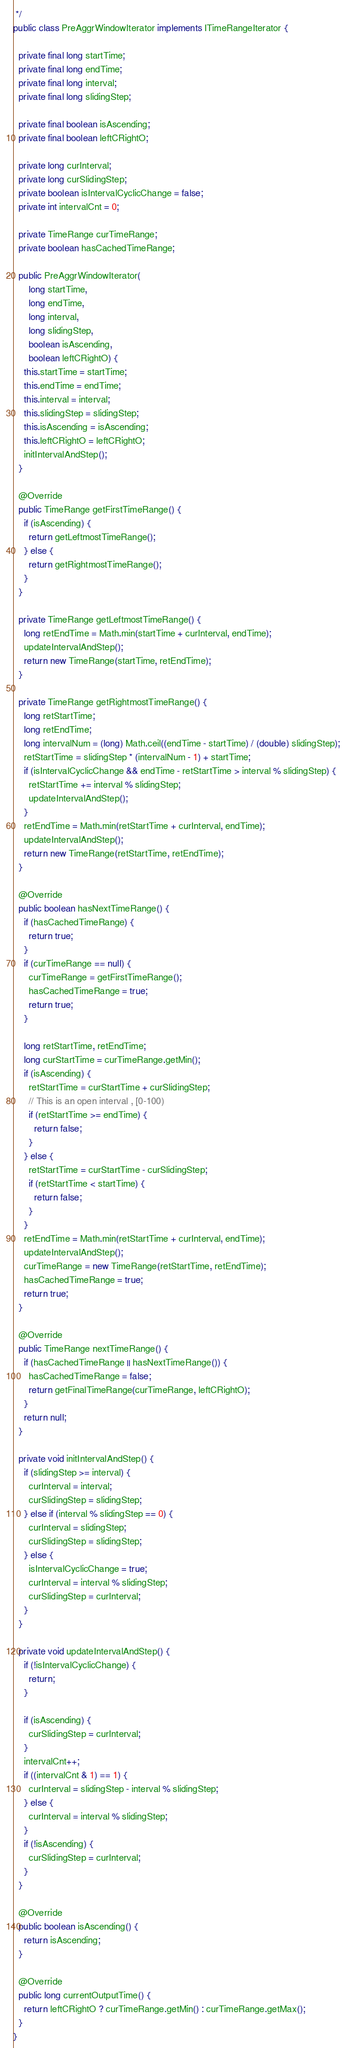Convert code to text. <code><loc_0><loc_0><loc_500><loc_500><_Java_> */
public class PreAggrWindowIterator implements ITimeRangeIterator {

  private final long startTime;
  private final long endTime;
  private final long interval;
  private final long slidingStep;

  private final boolean isAscending;
  private final boolean leftCRightO;

  private long curInterval;
  private long curSlidingStep;
  private boolean isIntervalCyclicChange = false;
  private int intervalCnt = 0;

  private TimeRange curTimeRange;
  private boolean hasCachedTimeRange;

  public PreAggrWindowIterator(
      long startTime,
      long endTime,
      long interval,
      long slidingStep,
      boolean isAscending,
      boolean leftCRightO) {
    this.startTime = startTime;
    this.endTime = endTime;
    this.interval = interval;
    this.slidingStep = slidingStep;
    this.isAscending = isAscending;
    this.leftCRightO = leftCRightO;
    initIntervalAndStep();
  }

  @Override
  public TimeRange getFirstTimeRange() {
    if (isAscending) {
      return getLeftmostTimeRange();
    } else {
      return getRightmostTimeRange();
    }
  }

  private TimeRange getLeftmostTimeRange() {
    long retEndTime = Math.min(startTime + curInterval, endTime);
    updateIntervalAndStep();
    return new TimeRange(startTime, retEndTime);
  }

  private TimeRange getRightmostTimeRange() {
    long retStartTime;
    long retEndTime;
    long intervalNum = (long) Math.ceil((endTime - startTime) / (double) slidingStep);
    retStartTime = slidingStep * (intervalNum - 1) + startTime;
    if (isIntervalCyclicChange && endTime - retStartTime > interval % slidingStep) {
      retStartTime += interval % slidingStep;
      updateIntervalAndStep();
    }
    retEndTime = Math.min(retStartTime + curInterval, endTime);
    updateIntervalAndStep();
    return new TimeRange(retStartTime, retEndTime);
  }

  @Override
  public boolean hasNextTimeRange() {
    if (hasCachedTimeRange) {
      return true;
    }
    if (curTimeRange == null) {
      curTimeRange = getFirstTimeRange();
      hasCachedTimeRange = true;
      return true;
    }

    long retStartTime, retEndTime;
    long curStartTime = curTimeRange.getMin();
    if (isAscending) {
      retStartTime = curStartTime + curSlidingStep;
      // This is an open interval , [0-100)
      if (retStartTime >= endTime) {
        return false;
      }
    } else {
      retStartTime = curStartTime - curSlidingStep;
      if (retStartTime < startTime) {
        return false;
      }
    }
    retEndTime = Math.min(retStartTime + curInterval, endTime);
    updateIntervalAndStep();
    curTimeRange = new TimeRange(retStartTime, retEndTime);
    hasCachedTimeRange = true;
    return true;
  }

  @Override
  public TimeRange nextTimeRange() {
    if (hasCachedTimeRange || hasNextTimeRange()) {
      hasCachedTimeRange = false;
      return getFinalTimeRange(curTimeRange, leftCRightO);
    }
    return null;
  }

  private void initIntervalAndStep() {
    if (slidingStep >= interval) {
      curInterval = interval;
      curSlidingStep = slidingStep;
    } else if (interval % slidingStep == 0) {
      curInterval = slidingStep;
      curSlidingStep = slidingStep;
    } else {
      isIntervalCyclicChange = true;
      curInterval = interval % slidingStep;
      curSlidingStep = curInterval;
    }
  }

  private void updateIntervalAndStep() {
    if (!isIntervalCyclicChange) {
      return;
    }

    if (isAscending) {
      curSlidingStep = curInterval;
    }
    intervalCnt++;
    if ((intervalCnt & 1) == 1) {
      curInterval = slidingStep - interval % slidingStep;
    } else {
      curInterval = interval % slidingStep;
    }
    if (!isAscending) {
      curSlidingStep = curInterval;
    }
  }

  @Override
  public boolean isAscending() {
    return isAscending;
  }

  @Override
  public long currentOutputTime() {
    return leftCRightO ? curTimeRange.getMin() : curTimeRange.getMax();
  }
}
</code> 